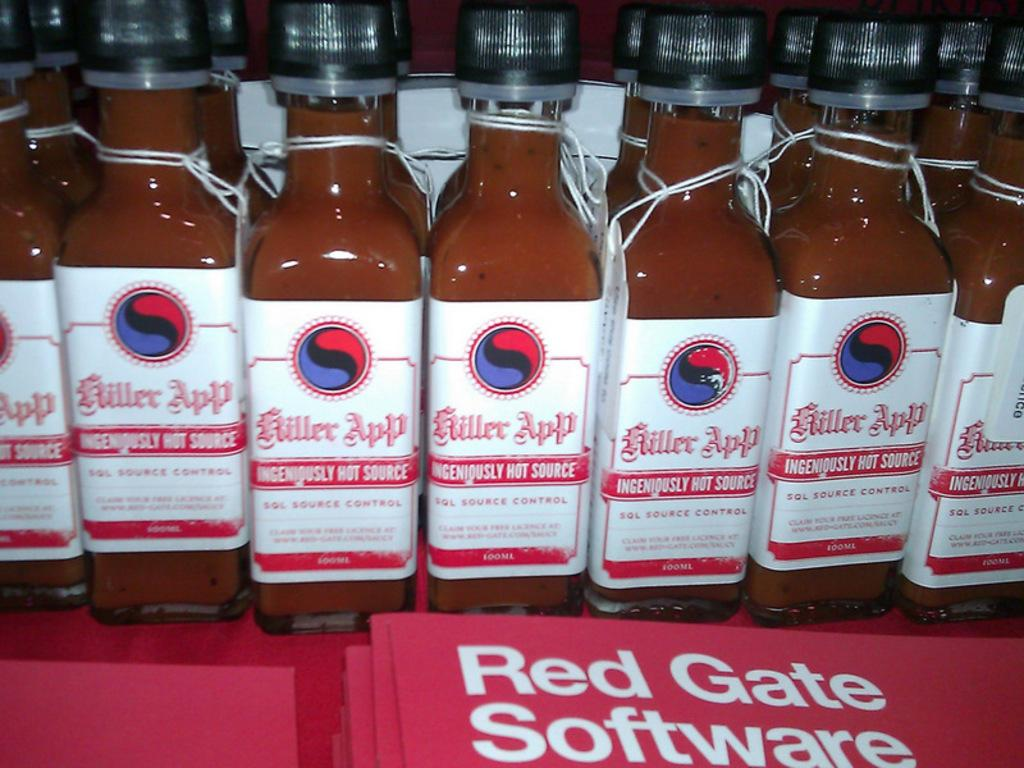<image>
Summarize the visual content of the image. Bottles of Killer App hot source placed next to each other. 